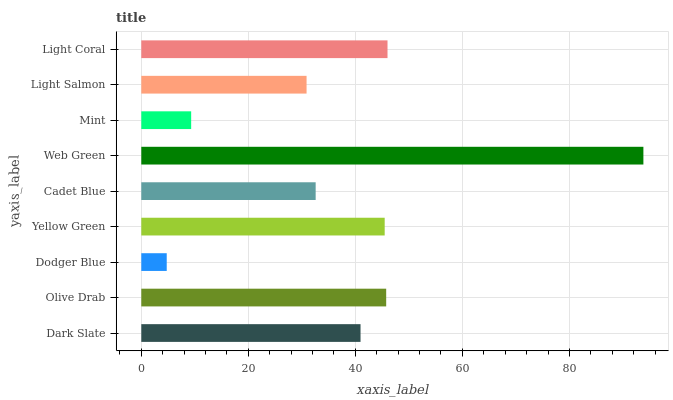Is Dodger Blue the minimum?
Answer yes or no. Yes. Is Web Green the maximum?
Answer yes or no. Yes. Is Olive Drab the minimum?
Answer yes or no. No. Is Olive Drab the maximum?
Answer yes or no. No. Is Olive Drab greater than Dark Slate?
Answer yes or no. Yes. Is Dark Slate less than Olive Drab?
Answer yes or no. Yes. Is Dark Slate greater than Olive Drab?
Answer yes or no. No. Is Olive Drab less than Dark Slate?
Answer yes or no. No. Is Dark Slate the high median?
Answer yes or no. Yes. Is Dark Slate the low median?
Answer yes or no. Yes. Is Cadet Blue the high median?
Answer yes or no. No. Is Light Salmon the low median?
Answer yes or no. No. 